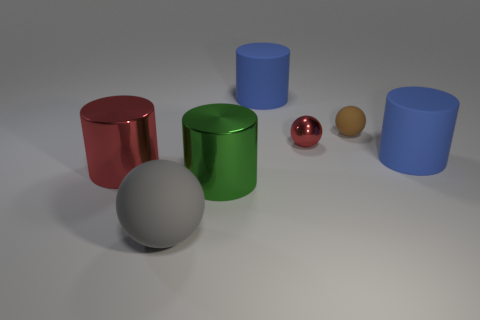Subtract all red cubes. How many blue cylinders are left? 2 Subtract all tiny red metal balls. How many balls are left? 2 Subtract 1 spheres. How many spheres are left? 2 Subtract all red cylinders. How many cylinders are left? 3 Add 3 large blue things. How many objects exist? 10 Subtract all spheres. How many objects are left? 4 Subtract all purple cylinders. Subtract all cyan balls. How many cylinders are left? 4 Subtract all large gray matte things. Subtract all small yellow rubber cylinders. How many objects are left? 6 Add 4 red metallic things. How many red metallic things are left? 6 Add 7 small rubber objects. How many small rubber objects exist? 8 